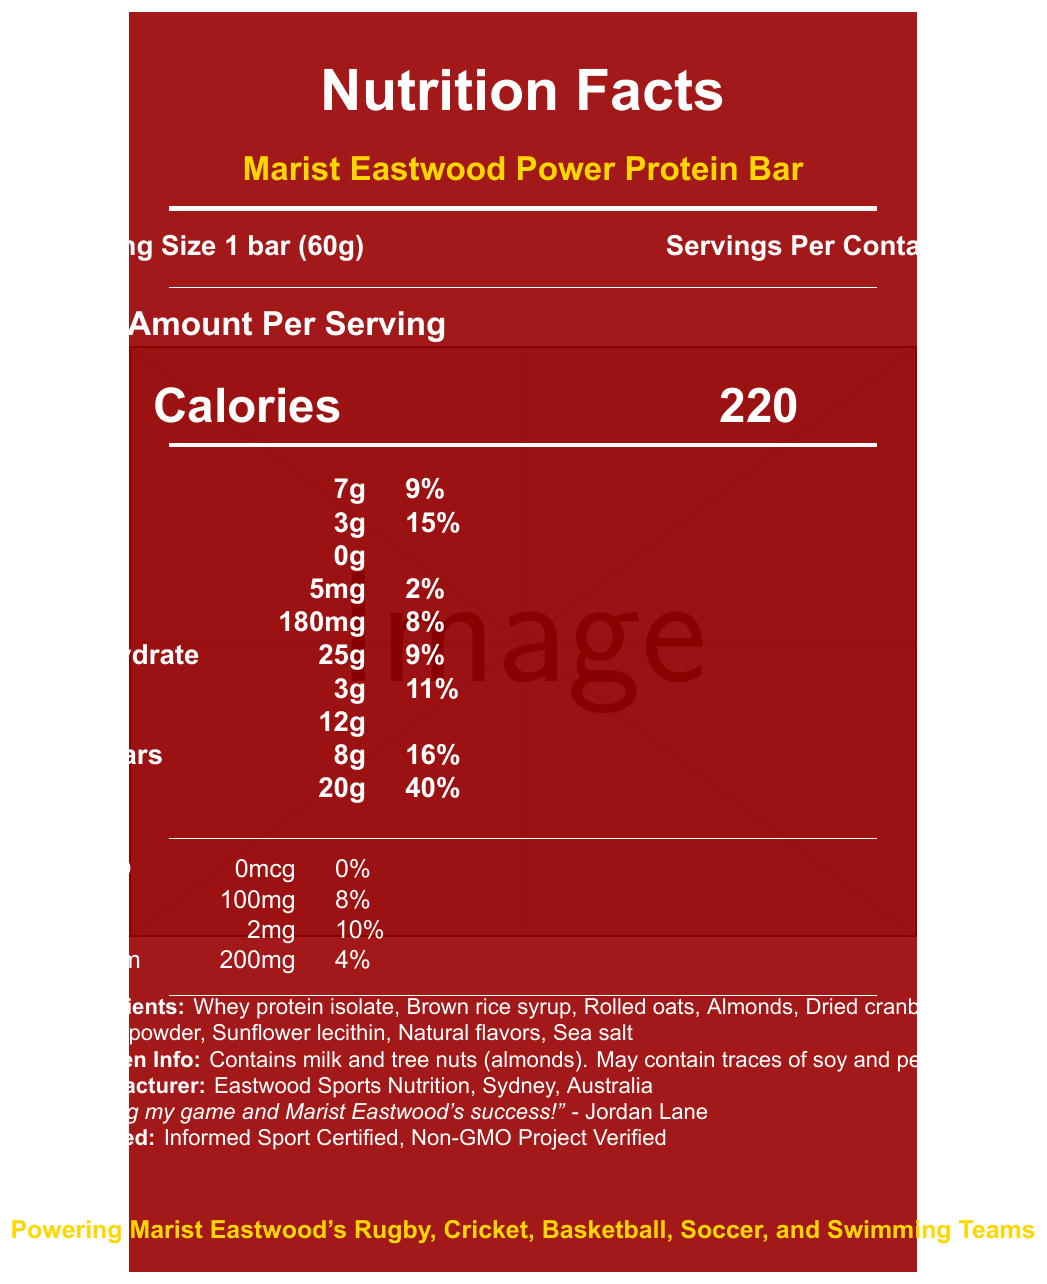what is the serving size of the Marist Eastwood Power Protein Bar? The document states "Serving Size 1 bar (60g)" at the top section.
Answer: 1 bar (60g) how many calories are in one serving of the Marist Eastwood Power Protein Bar? The document lists "Calories 220" in the nutrition facts section.
Answer: 220 how many grams of protein does one Marist Eastwood Power Protein Bar contain? The document mentions "Protein 20g" under the amount per serving.
Answer: 20g what is the sodium content in one serving of the Marist Eastwood Power Protein Bar? According to the nutrition facts, the bar contains "Sodium 180mg."
Answer: 180mg what allergens are mentioned for the Marist Eastwood Power Protein Bar? The document contains an allergen info section stating this information.
Answer: Contains milk and tree nuts (almonds). May contain traces of soy and peanuts. how many servings are there per container? The document states "Servings Per Container 12" at the top section.
Answer: 12 which ingredient is listed first in the Marist Eastwood Power Protein Bar? The ingredients section lists "Whey protein isolate" as the first ingredient.
Answer: Whey protein isolate what percentage of the daily value of protein does one bar provide? The document mentions "Protein 20g 40%" indicating it provides 40% of the daily value of protein.
Answer: 40% what type of certification does the Marist Eastwood Power Protein Bar have? A. Organic Certified B. Informed Sport Certified C. Vegan Certified The document states "Certified: Informed Sport Certified, Non-GMO Project Verified".
Answer: B total fat in one serving is: A. 5g B. 7g C. 9g D. 11g According to the document, the total fat content is "7g".
Answer: B is there any trans fat in the Marist Eastwood Power Protein Bar? The document lists "Trans Fat 0g," indicating there is no trans fat.
Answer: No what is the purpose of Jordan Lane's endorsement? The document contains the endorsement: "Fueling my game and Marist Eastwood's success!" by Jordan Lane.
Answer: Fueling my game and Marist Eastwood's success! which sports teams at Marist College Eastwood rely on this protein bar? At the bottom, the document notes that the bar powers these school teams.
Answer: Rugby, Cricket, Basketball, Soccer, and Swimming describe the main idea of the document The document includes detailed nutrition information, ingredients, allergens, endorsements, and certifications in a visually-appealing format relating to the sports teams of Marist College Eastwood.
Answer: The document provides the nutrition facts and details about the Marist Eastwood Power Protein Bar, highlighting its ingredients, allergen information, serving size, certifications, and endorsement by Jordan Lane. what is the price of one container of the Marist Eastwood Power Protein Bars? The document does not provide any information about the price of the protein bars.
Answer: Cannot be determined 